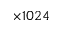<formula> <loc_0><loc_0><loc_500><loc_500>\times 1 0 2 4</formula> 